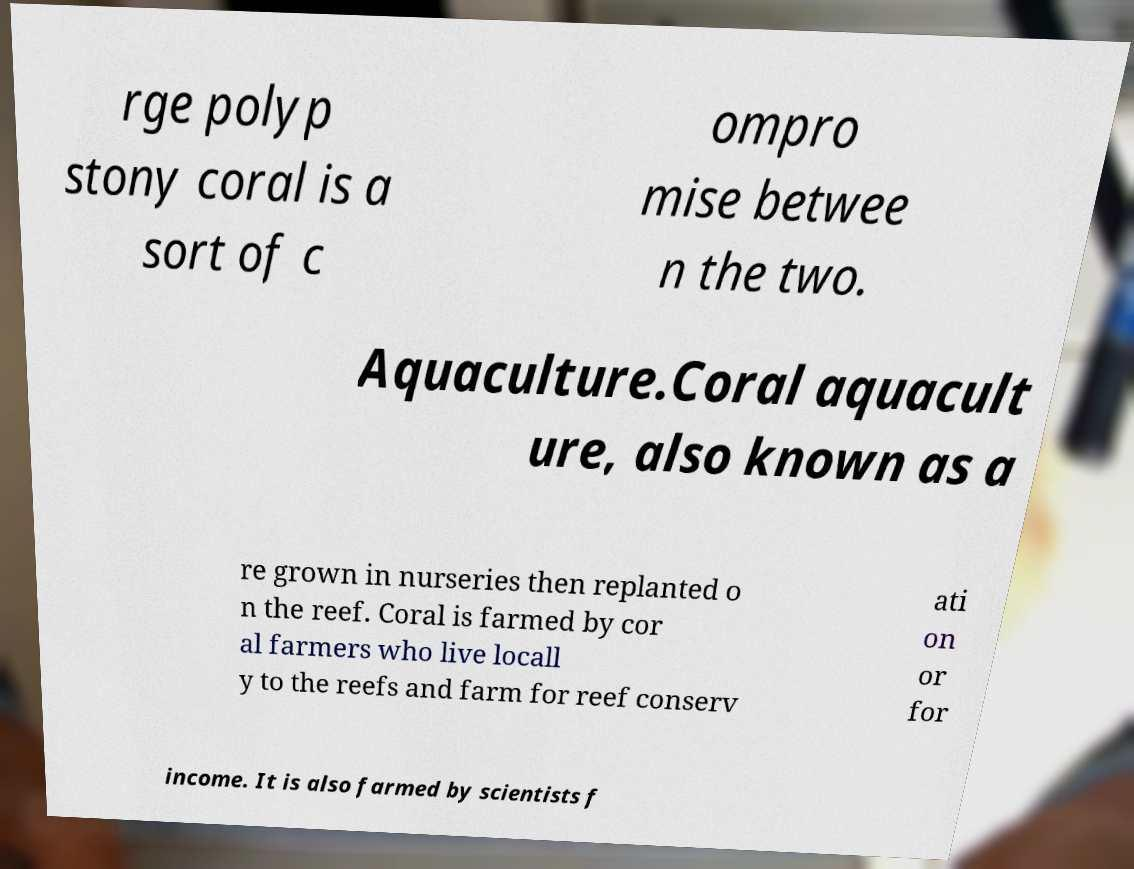Could you assist in decoding the text presented in this image and type it out clearly? rge polyp stony coral is a sort of c ompro mise betwee n the two. Aquaculture.Coral aquacult ure, also known as a re grown in nurseries then replanted o n the reef. Coral is farmed by cor al farmers who live locall y to the reefs and farm for reef conserv ati on or for income. It is also farmed by scientists f 